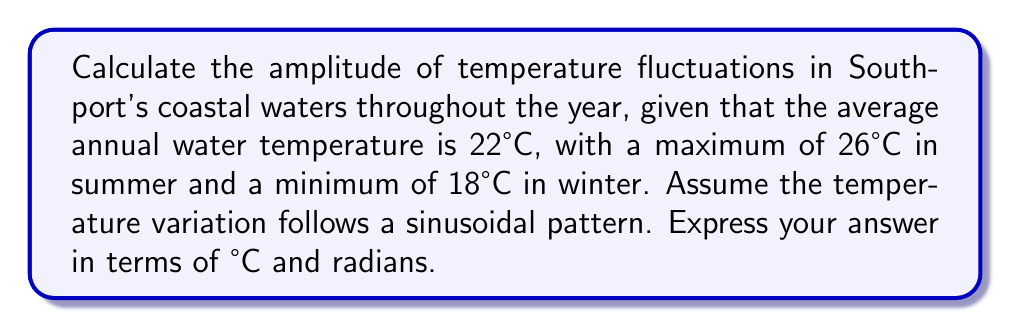Can you answer this question? Let's approach this step-by-step:

1) The temperature variation can be modeled using a sinusoidal function:

   $$T(t) = A \sin(\omega t + \phi) + T_0$$

   Where:
   $T(t)$ is the temperature at time $t$
   $A$ is the amplitude (what we're solving for)
   $\omega$ is the angular frequency
   $\phi$ is the phase shift
   $T_0$ is the average temperature

2) We know:
   - Average temperature $T_0 = 22°C$
   - Maximum temperature $T_{max} = 26°C$
   - Minimum temperature $T_{min} = 18°C$

3) The amplitude is half the difference between the maximum and minimum:

   $$A = \frac{T_{max} - T_{min}}{2} = \frac{26°C - 18°C}{2} = 4°C$$

4) For the angular frequency, we know there's one cycle per year:

   $$\omega = \frac{2\pi}{365 \text{ days}} \approx 0.0172 \text{ rad/day}$$

5) Therefore, our temperature function is:

   $$T(t) = 4 \sin(0.0172t + \phi) + 22$$

   Where $t$ is in days and $\phi$ depends on when we start counting (e.g., January 1st).
Answer: $4°C, 0.0172 \text{ rad/day}$ 